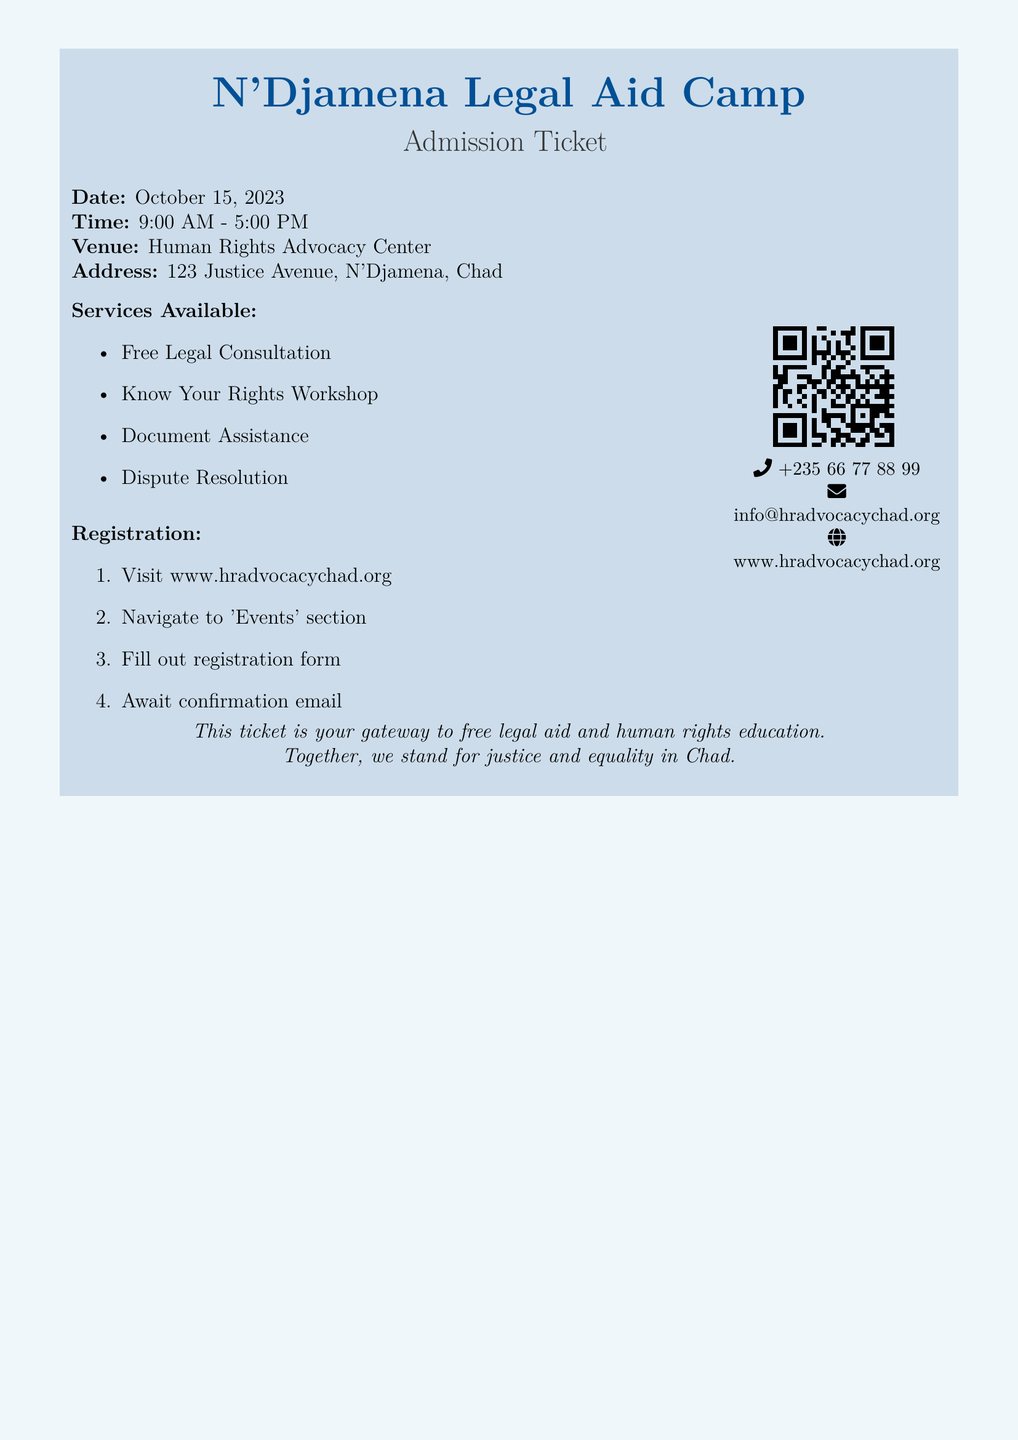What is the date of the legal aid camp? The date is explicitly stated in the document as October 15, 2023.
Answer: October 15, 2023 What time does the camp start? The document clearly states the starting time as part of the schedule.
Answer: 9:00 AM Where is the venue located? The address is specified in the document for the legal aid camp.
Answer: Human Rights Advocacy Center What type of services are provided? The document lists the services available at the camp in a bullet format.
Answer: Free Legal Consultation, Know Your Rights Workshop, Document Assistance, Dispute Resolution What do you need to do to register? The document provides a sequence of steps for registration in the 'Registration' section.
Answer: Visit www.hradvocacychad.org What is mentioned as the purpose of the ticket? The document states the purpose at the bottom for attendees.
Answer: Gateway to free legal aid and human rights education How can you contact the organizers? The contact information, including a phone number and email, is provided in the document.
Answer: +235 66 77 88 99 What kind of workshops are offered? The document mentions specific workshops related to rights in the services available.
Answer: Know Your Rights Workshop 